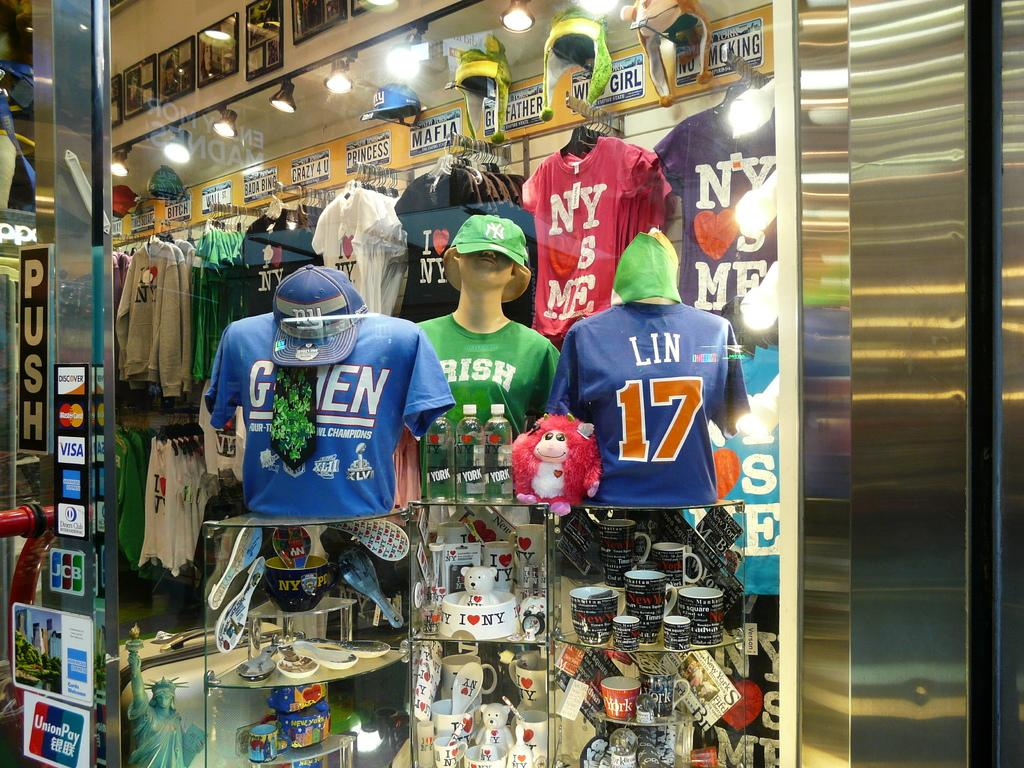Provide a one-sentence caption for the provided image. A display of t-shirts include a couple with a NY LOVES ME slogan. 